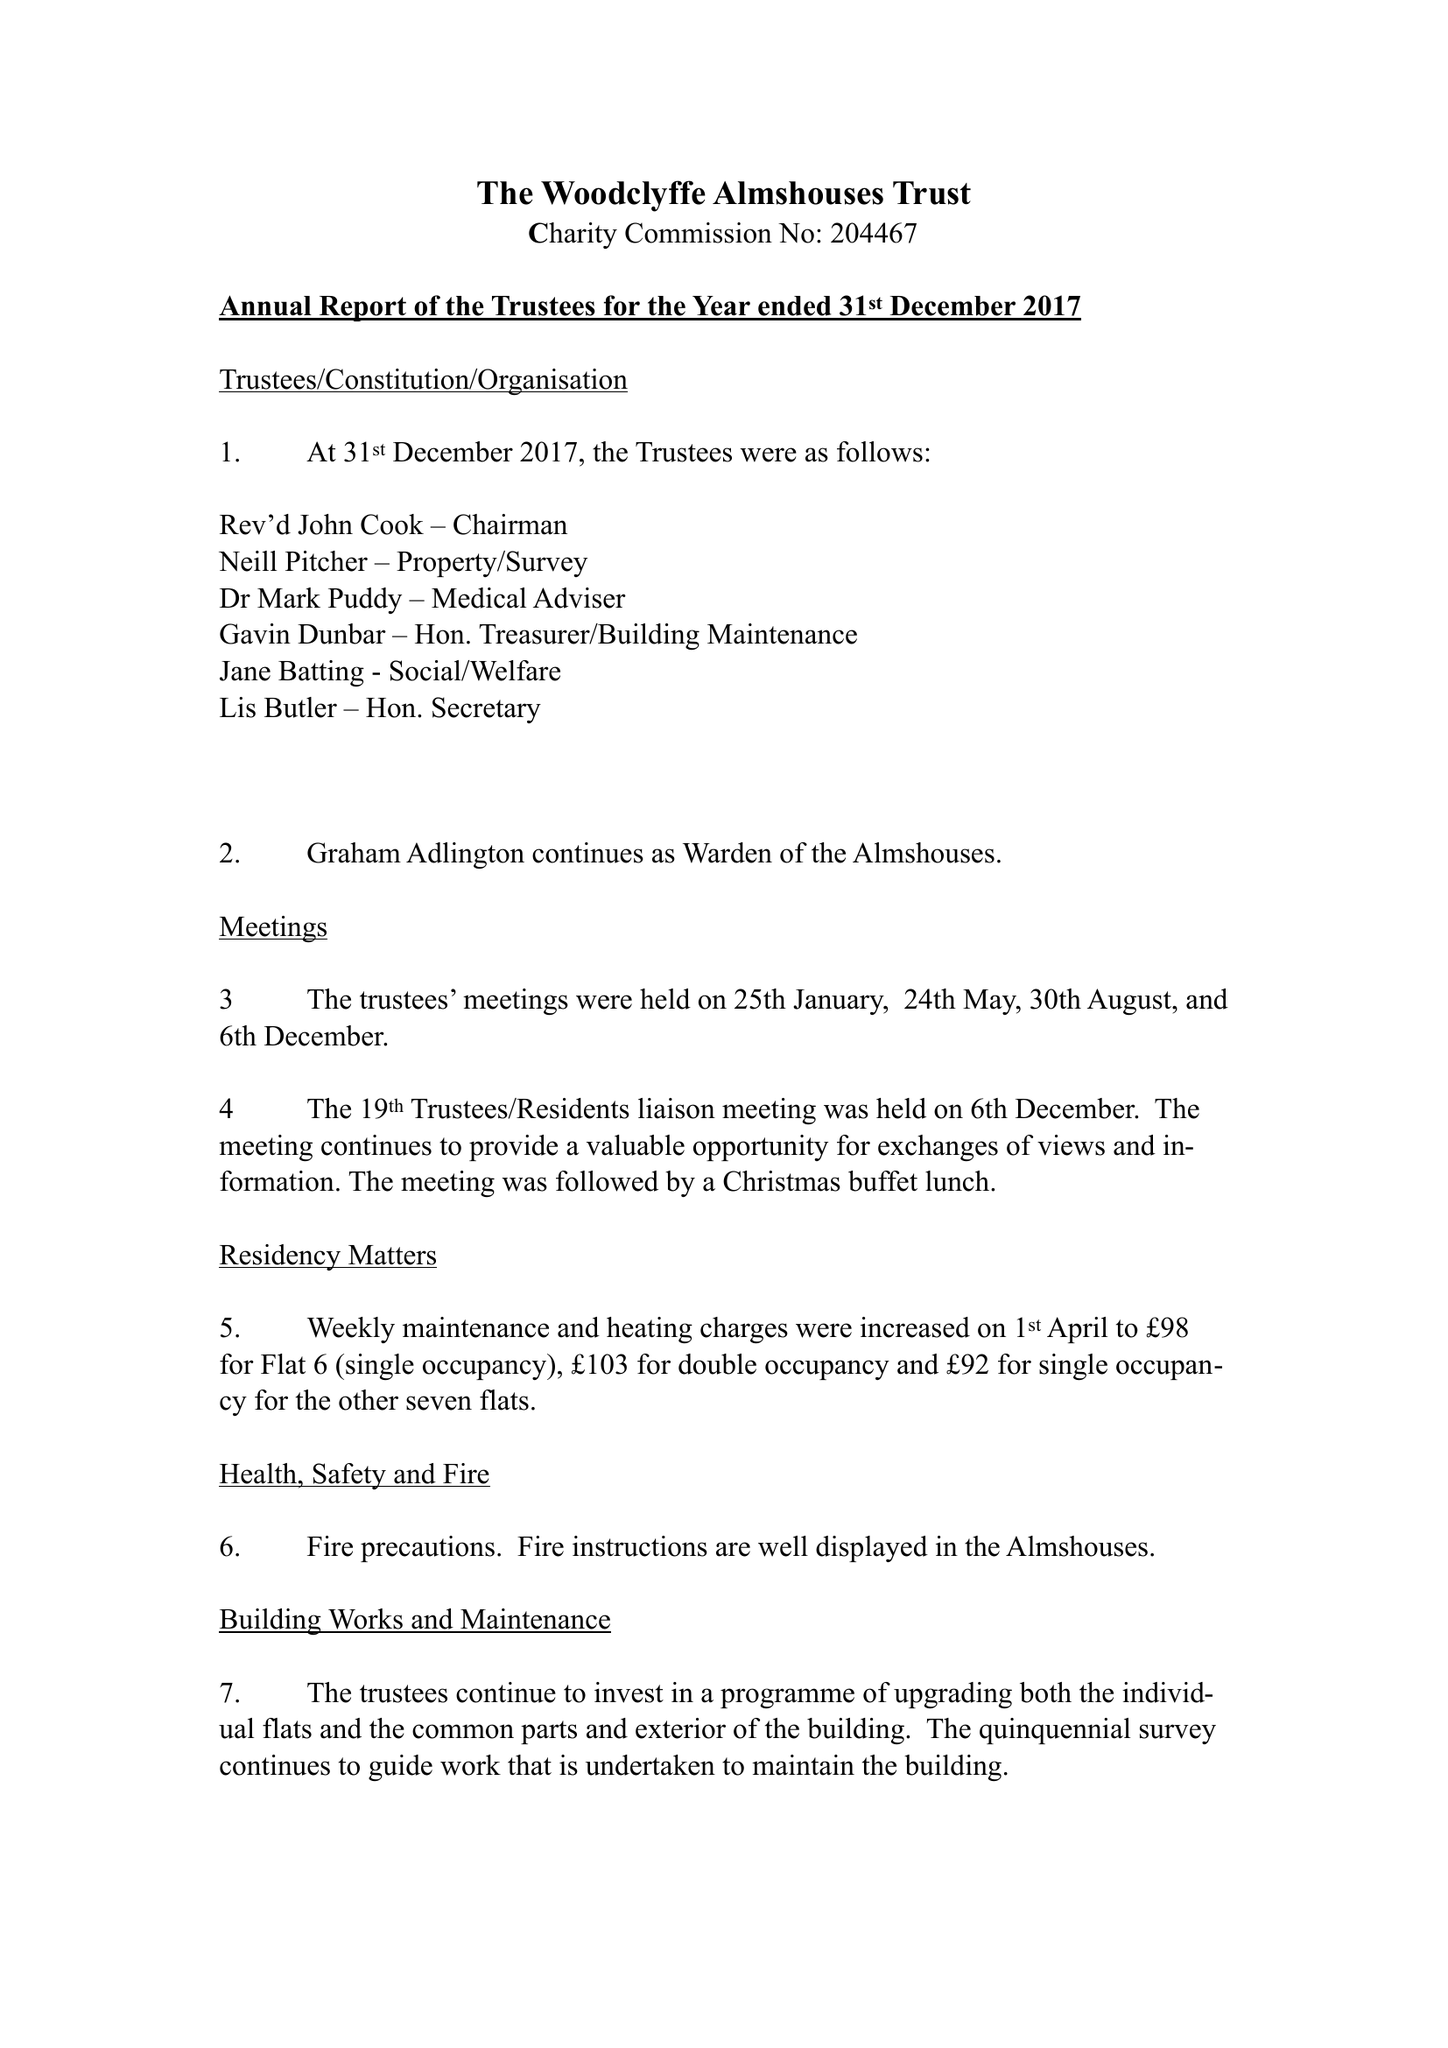What is the value for the spending_annually_in_british_pounds?
Answer the question using a single word or phrase. 44796.00 